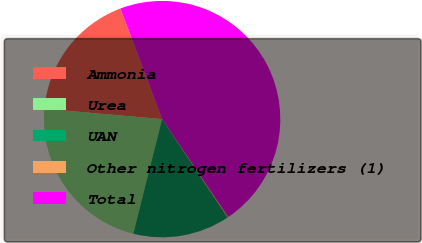<chart> <loc_0><loc_0><loc_500><loc_500><pie_chart><fcel>Ammonia<fcel>Urea<fcel>UAN<fcel>Other nitrogen fertilizers (1)<fcel>Total<nl><fcel>17.87%<fcel>22.48%<fcel>13.26%<fcel>0.13%<fcel>46.27%<nl></chart> 